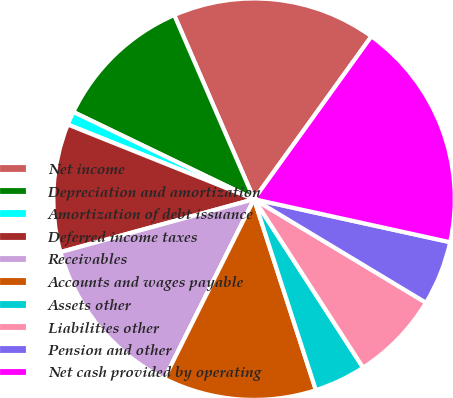<chart> <loc_0><loc_0><loc_500><loc_500><pie_chart><fcel>Net income<fcel>Depreciation and amortization<fcel>Amortization of debt issuance<fcel>Deferred income taxes<fcel>Receivables<fcel>Accounts and wages payable<fcel>Assets other<fcel>Liabilities other<fcel>Pension and other<fcel>Net cash provided by operating<nl><fcel>16.45%<fcel>11.33%<fcel>1.09%<fcel>10.31%<fcel>13.38%<fcel>12.36%<fcel>4.16%<fcel>7.23%<fcel>5.19%<fcel>18.5%<nl></chart> 